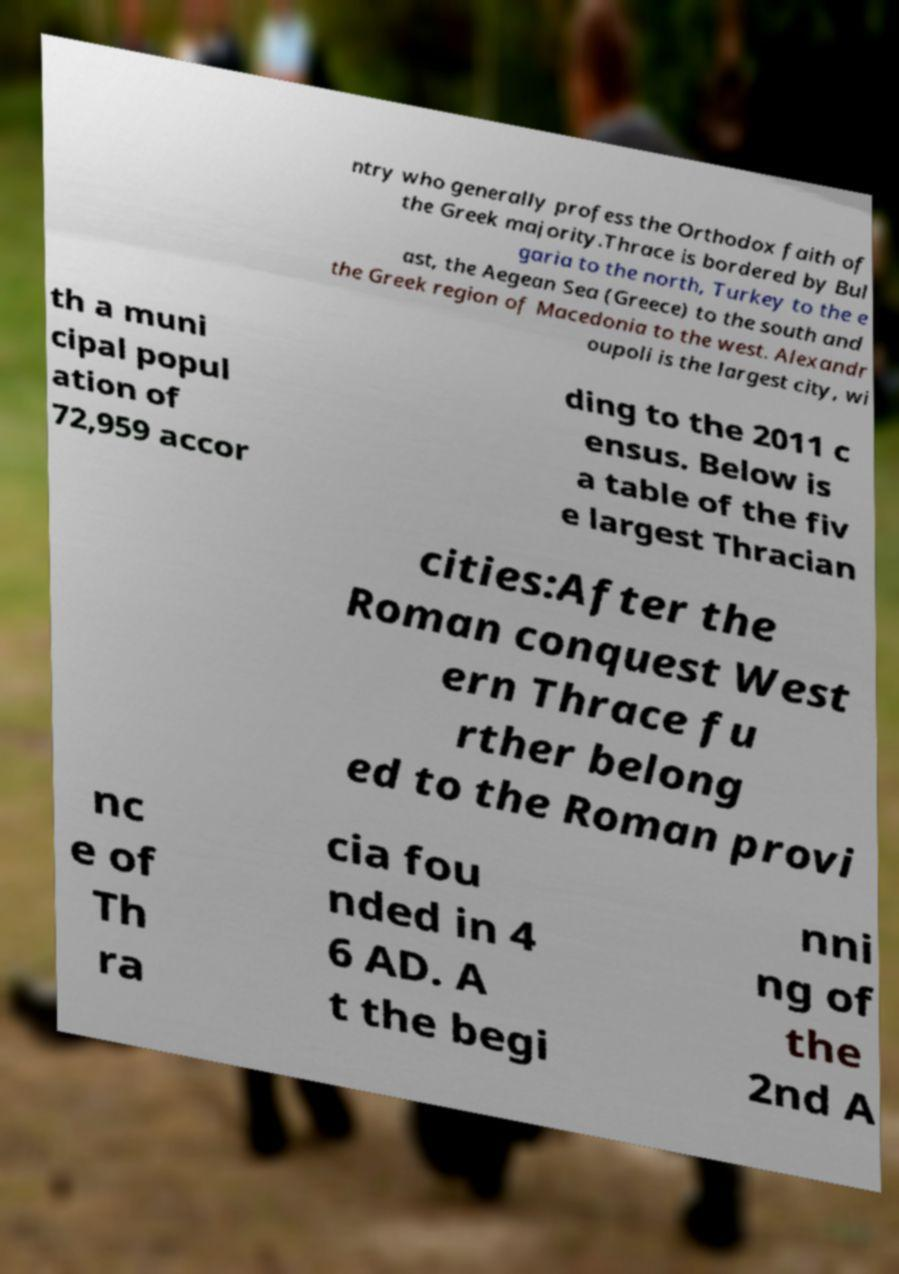What messages or text are displayed in this image? I need them in a readable, typed format. ntry who generally profess the Orthodox faith of the Greek majority.Thrace is bordered by Bul garia to the north, Turkey to the e ast, the Aegean Sea (Greece) to the south and the Greek region of Macedonia to the west. Alexandr oupoli is the largest city, wi th a muni cipal popul ation of 72,959 accor ding to the 2011 c ensus. Below is a table of the fiv e largest Thracian cities:After the Roman conquest West ern Thrace fu rther belong ed to the Roman provi nc e of Th ra cia fou nded in 4 6 AD. A t the begi nni ng of the 2nd A 